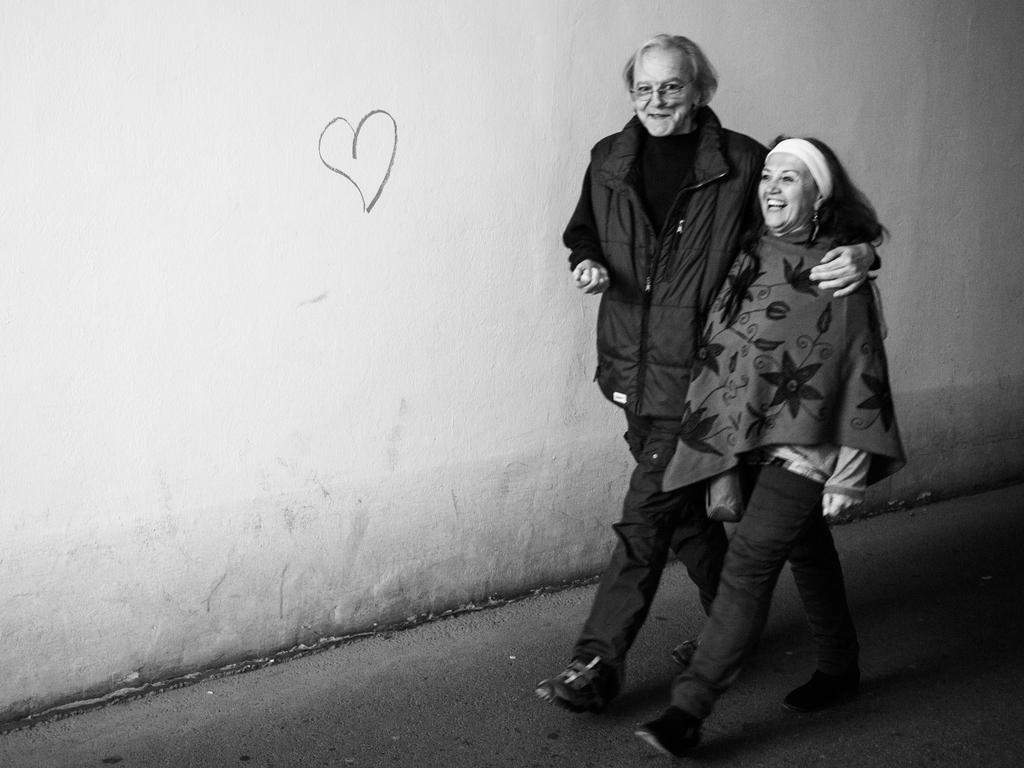How would you summarize this image in a sentence or two? In this image I can see a man and a woman are walking and smiling. In the background I can see the wall. 